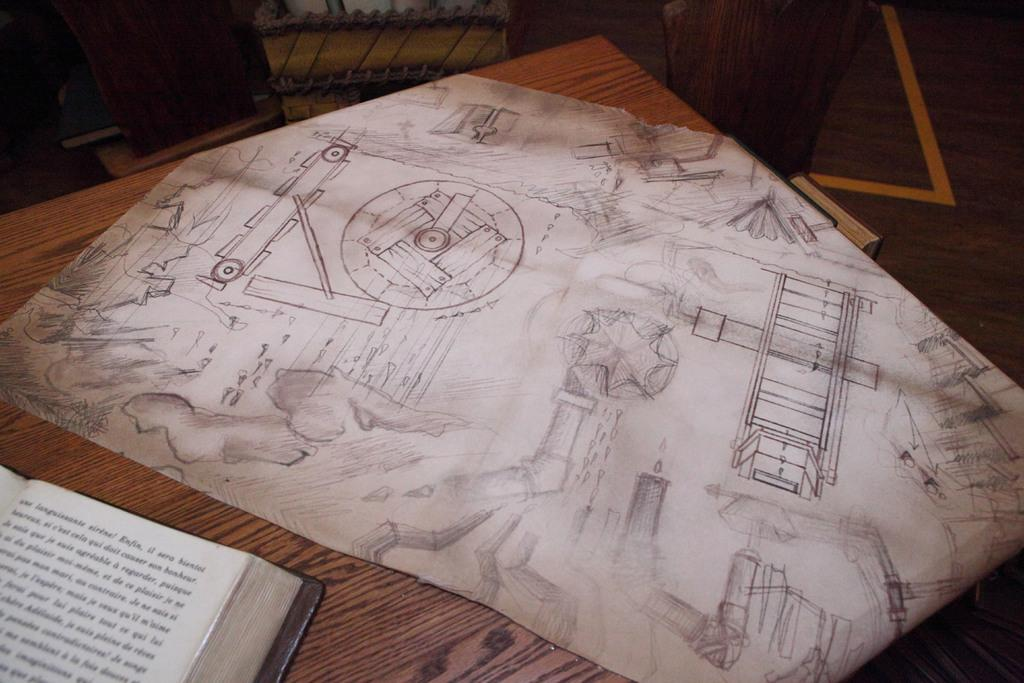What piece of furniture is present in the image? There is a table in the image. What object is placed on the table? There is a book on the table. What channel is the book tuned to in the image? The book is not a television or device that can be tuned to a channel; it is a physical object containing written or printed material. 